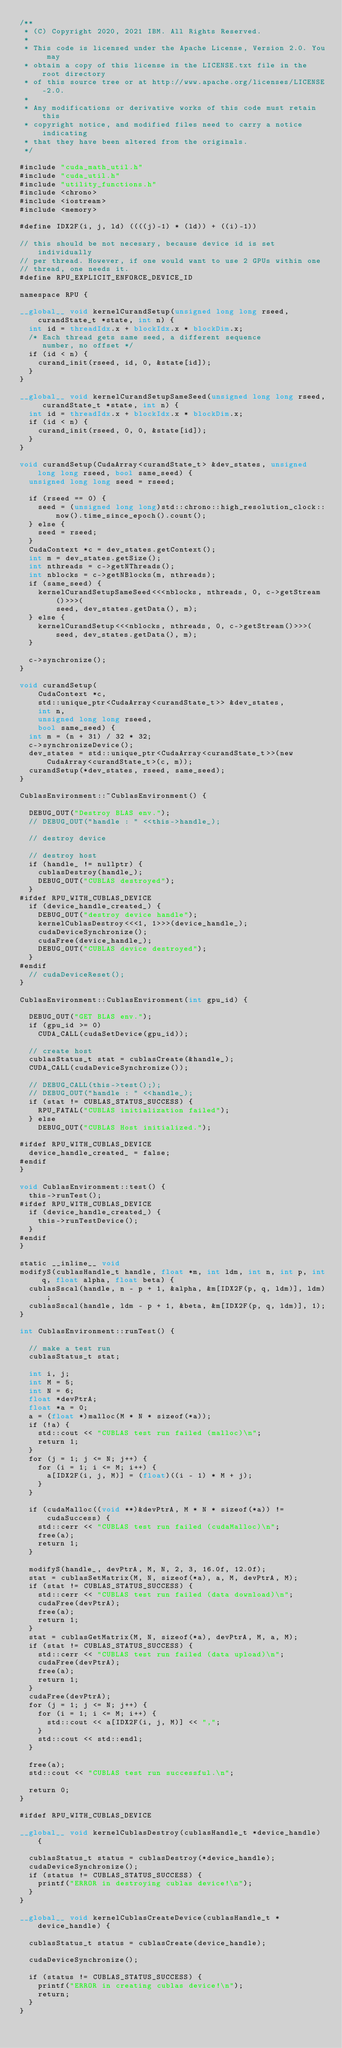Convert code to text. <code><loc_0><loc_0><loc_500><loc_500><_Cuda_>/**
 * (C) Copyright 2020, 2021 IBM. All Rights Reserved.
 *
 * This code is licensed under the Apache License, Version 2.0. You may
 * obtain a copy of this license in the LICENSE.txt file in the root directory
 * of this source tree or at http://www.apache.org/licenses/LICENSE-2.0.
 *
 * Any modifications or derivative works of this code must retain this
 * copyright notice, and modified files need to carry a notice indicating
 * that they have been altered from the originals.
 */

#include "cuda_math_util.h"
#include "cuda_util.h"
#include "utility_functions.h"
#include <chrono>
#include <iostream>
#include <memory>

#define IDX2F(i, j, ld) ((((j)-1) * (ld)) + ((i)-1))

// this should be not necesary, because device id is set individually
// per thread. However, if one would want to use 2 GPUs within one
// thread, one needs it.
#define RPU_EXPLICIT_ENFORCE_DEVICE_ID

namespace RPU {

__global__ void kernelCurandSetup(unsigned long long rseed, curandState_t *state, int n) {
  int id = threadIdx.x + blockIdx.x * blockDim.x;
  /* Each thread gets same seed, a different sequence
     number, no offset */
  if (id < n) {
    curand_init(rseed, id, 0, &state[id]);
  }
}

__global__ void kernelCurandSetupSameSeed(unsigned long long rseed, curandState_t *state, int n) {
  int id = threadIdx.x + blockIdx.x * blockDim.x;
  if (id < n) {
    curand_init(rseed, 0, 0, &state[id]);
  }
}

void curandSetup(CudaArray<curandState_t> &dev_states, unsigned long long rseed, bool same_seed) {
  unsigned long long seed = rseed;

  if (rseed == 0) {
    seed = (unsigned long long)std::chrono::high_resolution_clock::now().time_since_epoch().count();
  } else {
    seed = rseed;
  }
  CudaContext *c = dev_states.getContext();
  int m = dev_states.getSize();
  int nthreads = c->getNThreads();
  int nblocks = c->getNBlocks(m, nthreads);
  if (same_seed) {
    kernelCurandSetupSameSeed<<<nblocks, nthreads, 0, c->getStream()>>>(
        seed, dev_states.getData(), m);
  } else {
    kernelCurandSetup<<<nblocks, nthreads, 0, c->getStream()>>>(seed, dev_states.getData(), m);
  }

  c->synchronize();
}

void curandSetup(
    CudaContext *c,
    std::unique_ptr<CudaArray<curandState_t>> &dev_states,
    int n,
    unsigned long long rseed,
    bool same_seed) {
  int m = (n + 31) / 32 * 32;
  c->synchronizeDevice();
  dev_states = std::unique_ptr<CudaArray<curandState_t>>(new CudaArray<curandState_t>(c, m));
  curandSetup(*dev_states, rseed, same_seed);
}

CublasEnvironment::~CublasEnvironment() {

  DEBUG_OUT("Destroy BLAS env.");
  // DEBUG_OUT("handle : " <<this->handle_);

  // destroy device

  // destroy host
  if (handle_ != nullptr) {
    cublasDestroy(handle_);
    DEBUG_OUT("CUBLAS destroyed");
  }
#ifdef RPU_WITH_CUBLAS_DEVICE
  if (device_handle_created_) {
    DEBUG_OUT("destroy device handle");
    kernelCublasDestroy<<<1, 1>>>(device_handle_);
    cudaDeviceSynchronize();
    cudaFree(device_handle_);
    DEBUG_OUT("CUBLAS device destroyed");
  }
#endif
  // cudaDeviceReset();
}

CublasEnvironment::CublasEnvironment(int gpu_id) {

  DEBUG_OUT("GET BLAS env.");
  if (gpu_id >= 0)
    CUDA_CALL(cudaSetDevice(gpu_id));

  // create host
  cublasStatus_t stat = cublasCreate(&handle_);
  CUDA_CALL(cudaDeviceSynchronize());

  // DEBUG_CALL(this->test(););
  // DEBUG_OUT("handle : " <<handle_);
  if (stat != CUBLAS_STATUS_SUCCESS) {
    RPU_FATAL("CUBLAS initialization failed");
  } else
    DEBUG_OUT("CUBLAS Host initialized.");

#ifdef RPU_WITH_CUBLAS_DEVICE
  device_handle_created_ = false;
#endif
}

void CublasEnvironment::test() {
  this->runTest();
#ifdef RPU_WITH_CUBLAS_DEVICE
  if (device_handle_created_) {
    this->runTestDevice();
  }
#endif
}

static __inline__ void
modifyS(cublasHandle_t handle, float *m, int ldm, int n, int p, int q, float alpha, float beta) {
  cublasSscal(handle, n - p + 1, &alpha, &m[IDX2F(p, q, ldm)], ldm);
  cublasSscal(handle, ldm - p + 1, &beta, &m[IDX2F(p, q, ldm)], 1);
}

int CublasEnvironment::runTest() {

  // make a test run
  cublasStatus_t stat;

  int i, j;
  int M = 5;
  int N = 6;
  float *devPtrA;
  float *a = 0;
  a = (float *)malloc(M * N * sizeof(*a));
  if (!a) {
    std::cout << "CUBLAS test run failed (malloc)\n";
    return 1;
  }
  for (j = 1; j <= N; j++) {
    for (i = 1; i <= M; i++) {
      a[IDX2F(i, j, M)] = (float)((i - 1) * M + j);
    }
  }

  if (cudaMalloc((void **)&devPtrA, M * N * sizeof(*a)) != cudaSuccess) {
    std::cerr << "CUBLAS test run failed (cudaMalloc)\n";
    free(a);
    return 1;
  }

  modifyS(handle_, devPtrA, M, N, 2, 3, 16.0f, 12.0f);
  stat = cublasSetMatrix(M, N, sizeof(*a), a, M, devPtrA, M);
  if (stat != CUBLAS_STATUS_SUCCESS) {
    std::cerr << "CUBLAS test run failed (data download)\n";
    cudaFree(devPtrA);
    free(a);
    return 1;
  }
  stat = cublasGetMatrix(M, N, sizeof(*a), devPtrA, M, a, M);
  if (stat != CUBLAS_STATUS_SUCCESS) {
    std::cerr << "CUBLAS test run failed (data upload)\n";
    cudaFree(devPtrA);
    free(a);
    return 1;
  }
  cudaFree(devPtrA);
  for (j = 1; j <= N; j++) {
    for (i = 1; i <= M; i++) {
      std::cout << a[IDX2F(i, j, M)] << ",";
    }
    std::cout << std::endl;
  }

  free(a);
  std::cout << "CUBLAS test run successful.\n";

  return 0;
}

#ifdef RPU_WITH_CUBLAS_DEVICE

__global__ void kernelCublasDestroy(cublasHandle_t *device_handle) {

  cublasStatus_t status = cublasDestroy(*device_handle);
  cudaDeviceSynchronize();
  if (status != CUBLAS_STATUS_SUCCESS) {
    printf("ERROR in destroying cublas device!\n");
  }
}

__global__ void kernelCublasCreateDevice(cublasHandle_t *device_handle) {

  cublasStatus_t status = cublasCreate(device_handle);

  cudaDeviceSynchronize();

  if (status != CUBLAS_STATUS_SUCCESS) {
    printf("ERROR in creating cublas device!\n");
    return;
  }
}
</code> 